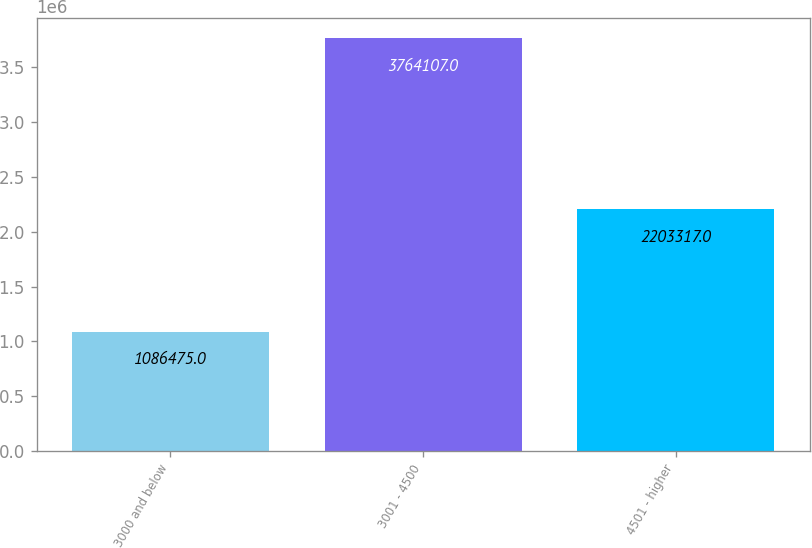Convert chart to OTSL. <chart><loc_0><loc_0><loc_500><loc_500><bar_chart><fcel>3000 and below<fcel>3001 - 4500<fcel>4501 - higher<nl><fcel>1.08648e+06<fcel>3.76411e+06<fcel>2.20332e+06<nl></chart> 